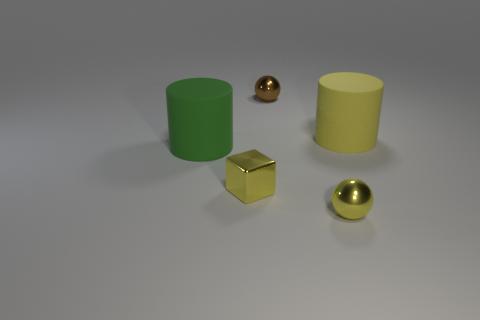Add 3 big yellow rubber cylinders. How many objects exist? 8 Subtract 1 blocks. How many blocks are left? 0 Add 5 brown shiny balls. How many brown shiny balls are left? 6 Add 1 tiny metal objects. How many tiny metal objects exist? 4 Subtract 0 red cylinders. How many objects are left? 5 Subtract all cylinders. How many objects are left? 3 Subtract all cyan cylinders. Subtract all yellow balls. How many cylinders are left? 2 Subtract all brown balls. How many yellow cylinders are left? 1 Subtract all large yellow matte objects. Subtract all small yellow things. How many objects are left? 2 